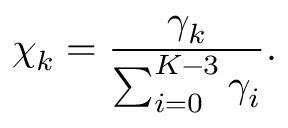<formula> <loc_0><loc_0><loc_500><loc_500>\chi _ { k } = \frac { \gamma _ { k } } { \sum _ { i = 0 } ^ { K - 3 } \gamma _ { i } } .</formula> 